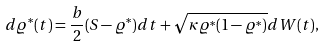<formula> <loc_0><loc_0><loc_500><loc_500>d \varrho ^ { * } ( t ) = \frac { b } { 2 } ( S - \varrho ^ { * } ) d t + \sqrt { \kappa \varrho ^ { * } ( 1 - \varrho ^ { * } ) } d W ( t ) ,</formula> 